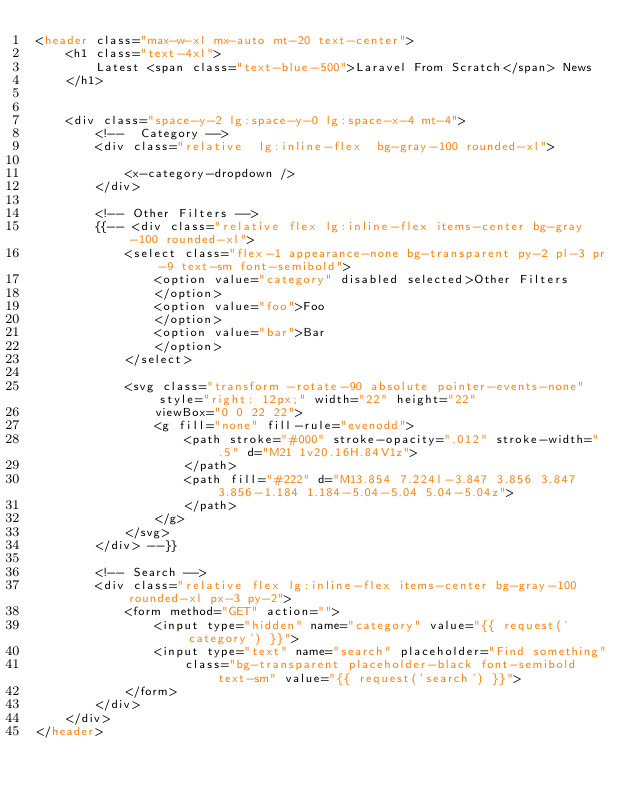<code> <loc_0><loc_0><loc_500><loc_500><_PHP_><header class="max-w-xl mx-auto mt-20 text-center">
    <h1 class="text-4xl">
        Latest <span class="text-blue-500">Laravel From Scratch</span> News
    </h1>


    <div class="space-y-2 lg:space-y-0 lg:space-x-4 mt-4">
        <!--  Category -->
        <div class="relative  lg:inline-flex  bg-gray-100 rounded-xl">

            <x-category-dropdown />
        </div>

        <!-- Other Filters -->
        {{-- <div class="relative flex lg:inline-flex items-center bg-gray-100 rounded-xl">
            <select class="flex-1 appearance-none bg-transparent py-2 pl-3 pr-9 text-sm font-semibold">
                <option value="category" disabled selected>Other Filters
                </option>
                <option value="foo">Foo
                </option>
                <option value="bar">Bar
                </option>
            </select>

            <svg class="transform -rotate-90 absolute pointer-events-none" style="right: 12px;" width="22" height="22"
                viewBox="0 0 22 22">
                <g fill="none" fill-rule="evenodd">
                    <path stroke="#000" stroke-opacity=".012" stroke-width=".5" d="M21 1v20.16H.84V1z">
                    </path>
                    <path fill="#222" d="M13.854 7.224l-3.847 3.856 3.847 3.856-1.184 1.184-5.04-5.04 5.04-5.04z">
                    </path>
                </g>
            </svg>
        </div> --}}

        <!-- Search -->
        <div class="relative flex lg:inline-flex items-center bg-gray-100 rounded-xl px-3 py-2">
            <form method="GET" action="">
                <input type="hidden" name="category" value="{{ request('category') }}">
                <input type="text" name="search" placeholder="Find something"
                    class="bg-transparent placeholder-black font-semibold text-sm" value="{{ request('search') }}">
            </form>
        </div>
    </div>
</header>
</code> 